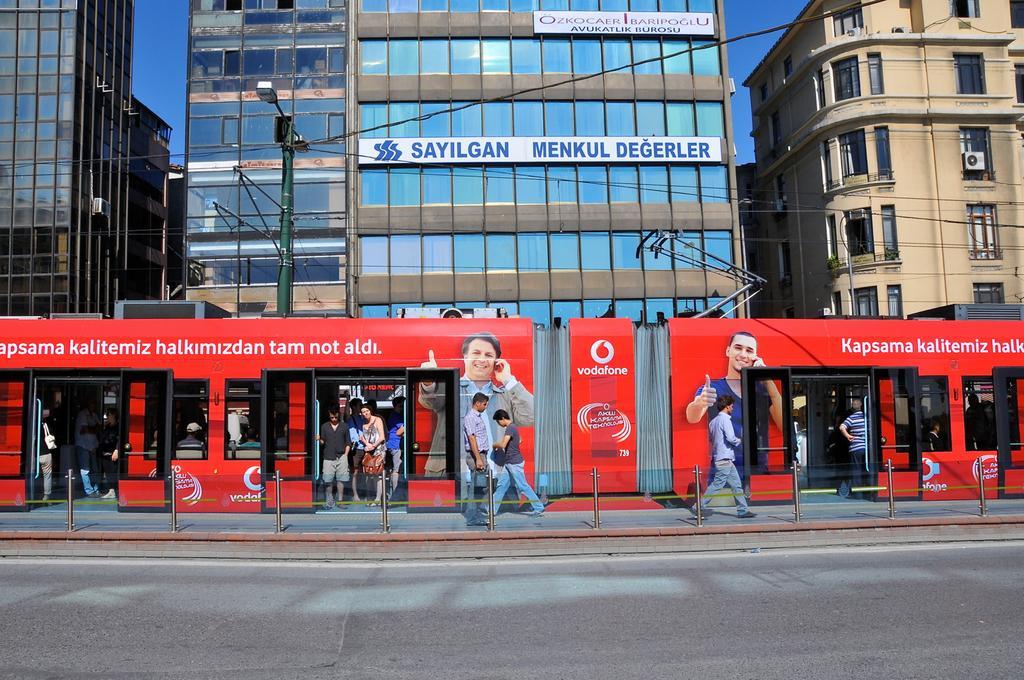Please provide a concise description of this image. In this picture we can see a road. There are a few people walking on the path. We can see some people in the train. There is a street light and a few buildings in the background. 